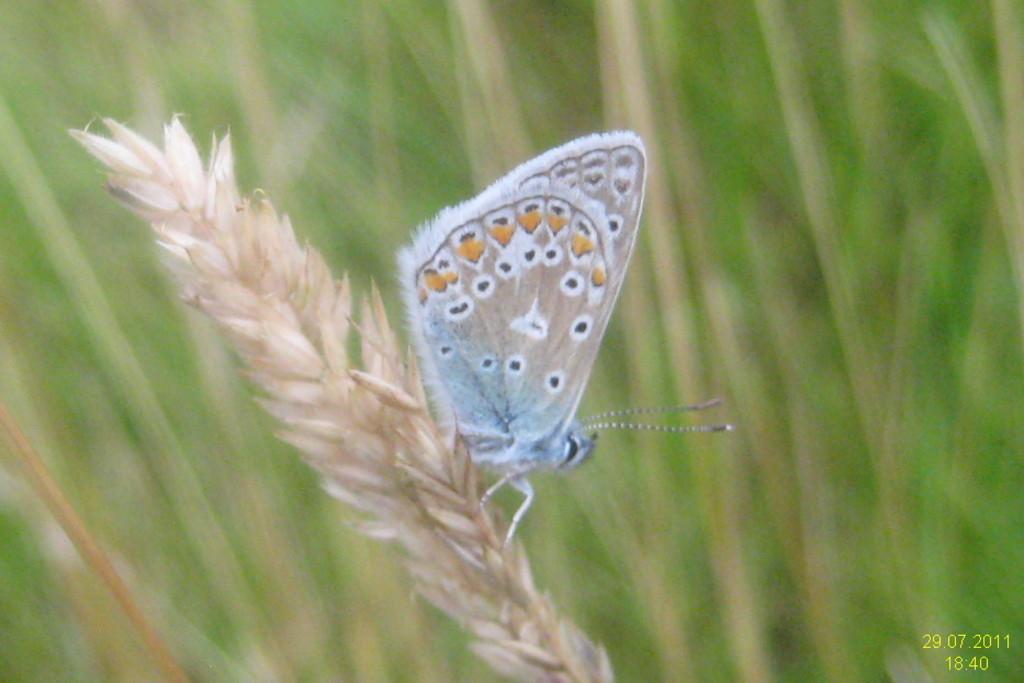Please provide a concise description of this image. In the image there is a stem with rice grains on that stem there is a butterfly. There is a green color background. In the right bottom of the image there is a time and date. 